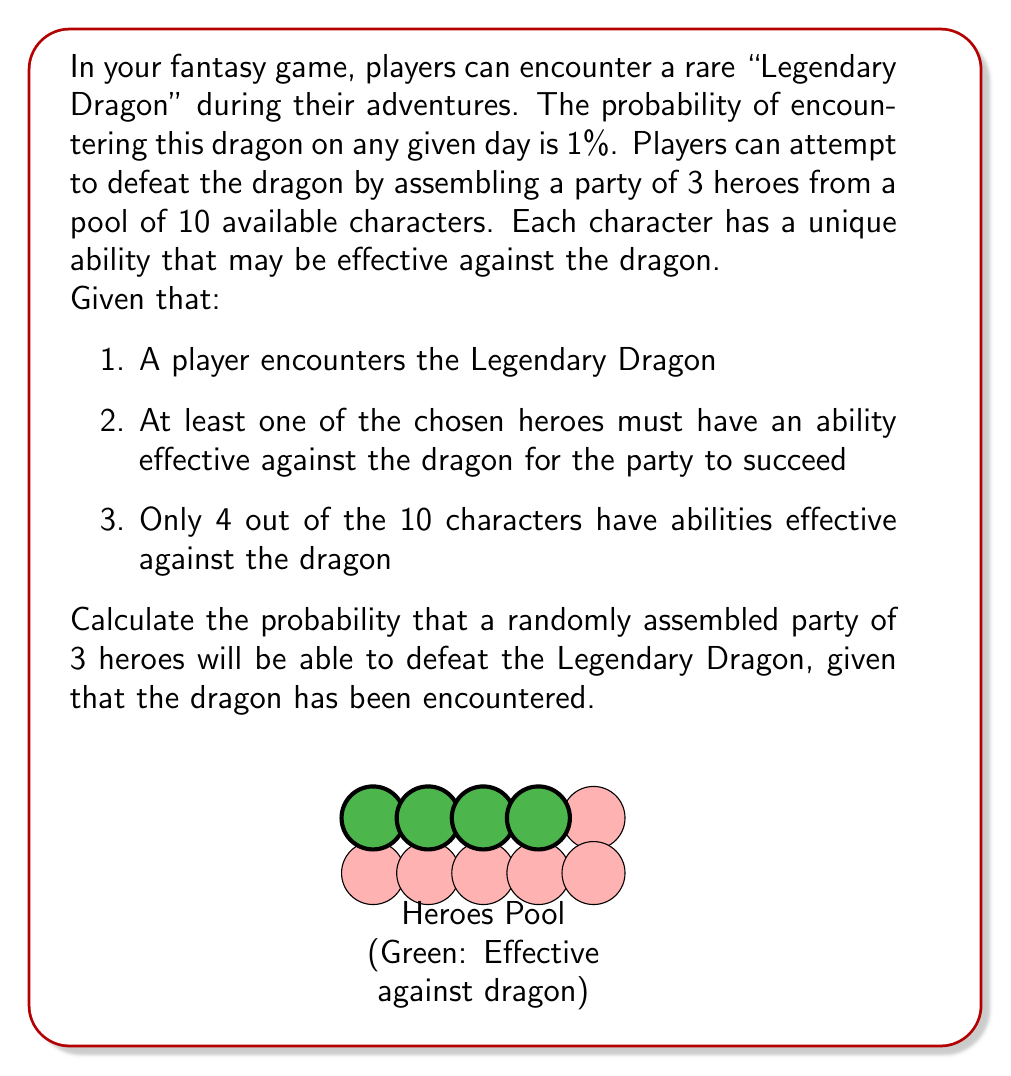Show me your answer to this math problem. Let's approach this step-by-step:

1) First, we need to calculate the total number of ways to choose 3 heroes from 10. This is a combination problem, denoted as $\binom{10}{3}$ or C(10,3).

   $$\binom{10}{3} = \frac{10!}{3!(10-3)!} = \frac{10!}{3!7!} = 120$$

2) Now, we need to calculate the number of ways to choose a party that has at least one hero effective against the dragon. It's easier to calculate this by subtracting the number of unfavorable outcomes from the total outcomes.

3) The unfavorable outcome is choosing all 3 heroes from the 6 ineffective heroes. This is denoted as $\binom{6}{3}$.

   $$\binom{6}{3} = \frac{6!}{3!(6-3)!} = \frac{6!}{3!3!} = 20$$

4) Therefore, the number of favorable outcomes (parties with at least one effective hero) is:

   $$120 - 20 = 100$$

5) The probability is the number of favorable outcomes divided by the total number of outcomes:

   $$P(\text{Effective Party}) = \frac{100}{120} = \frac{5}{6} \approx 0.8333$$

6) This means that given the Legendary Dragon is encountered, there's about an 83.33% chance that a randomly assembled party will be able to defeat it.
Answer: $\frac{5}{6}$ or approximately 0.8333 (83.33%) 